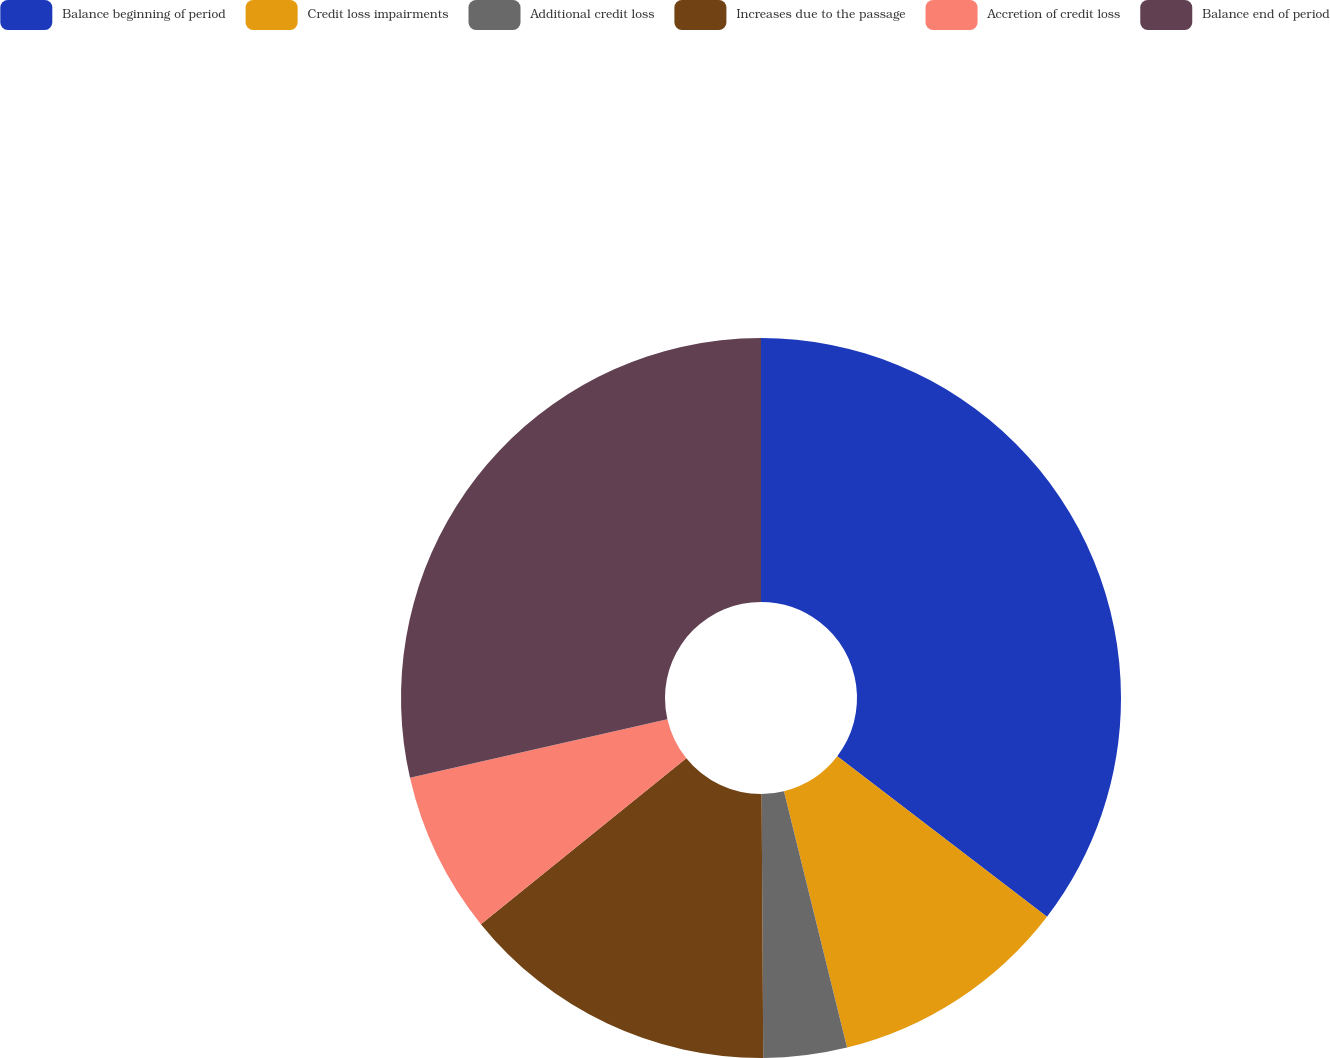Convert chart. <chart><loc_0><loc_0><loc_500><loc_500><pie_chart><fcel>Balance beginning of period<fcel>Credit loss impairments<fcel>Additional credit loss<fcel>Increases due to the passage<fcel>Accretion of credit loss<fcel>Balance end of period<nl><fcel>35.39%<fcel>10.77%<fcel>3.74%<fcel>14.29%<fcel>7.25%<fcel>28.56%<nl></chart> 